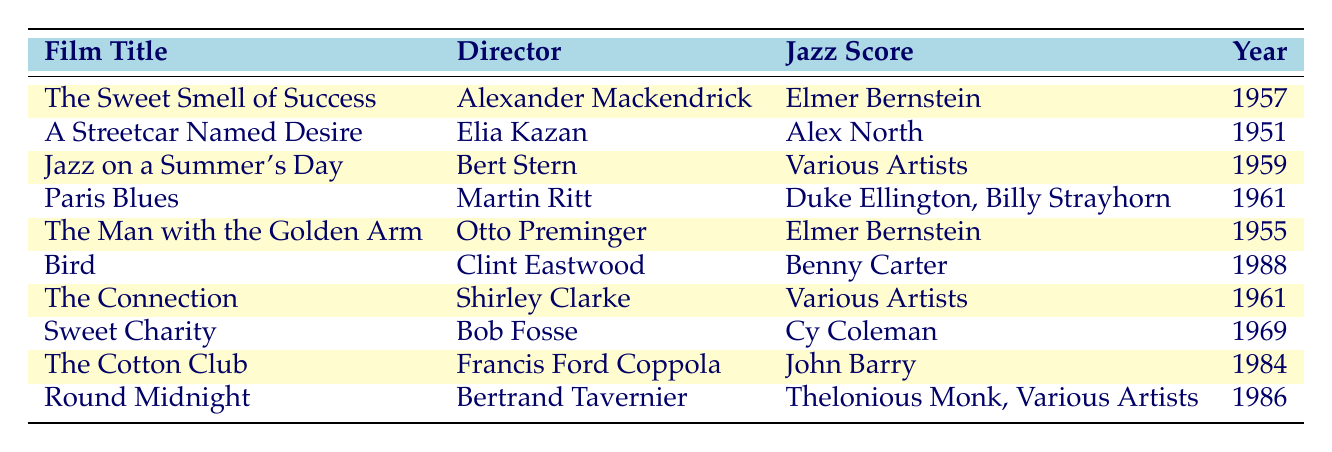What is the jazz score for "Bird"? Referring to the table, the row for "Bird" lists the jazz score as "Benny Carter."
Answer: Benny Carter Who directed "The Sweet Smell of Success"? The table shows that the film "The Sweet Smell of Success" was directed by "Alexander Mackendrick."
Answer: Alexander Mackendrick How many films were directed by Elia Kazan? There is only one film listed for Elia Kazan in the table, which is "A Streetcar Named Desire."
Answer: 1 Is "Jazz on a Summer's Day" released before "Round Midnight"? Comparing the years in the table, "Jazz on a Summer's Day" was released in 1959 and "Round Midnight" in 1986. Since 1959 is earlier than 1986, the statement is true.
Answer: Yes Which director had the most films listed in the table? By examining the directors and their corresponding films, it appears that each director has a different count of films listed. However, there are no repetitions of any directors; hence, none of the directors is repeated. It's clear that "each director has only one film in this list."
Answer: Each director has only one film listed 